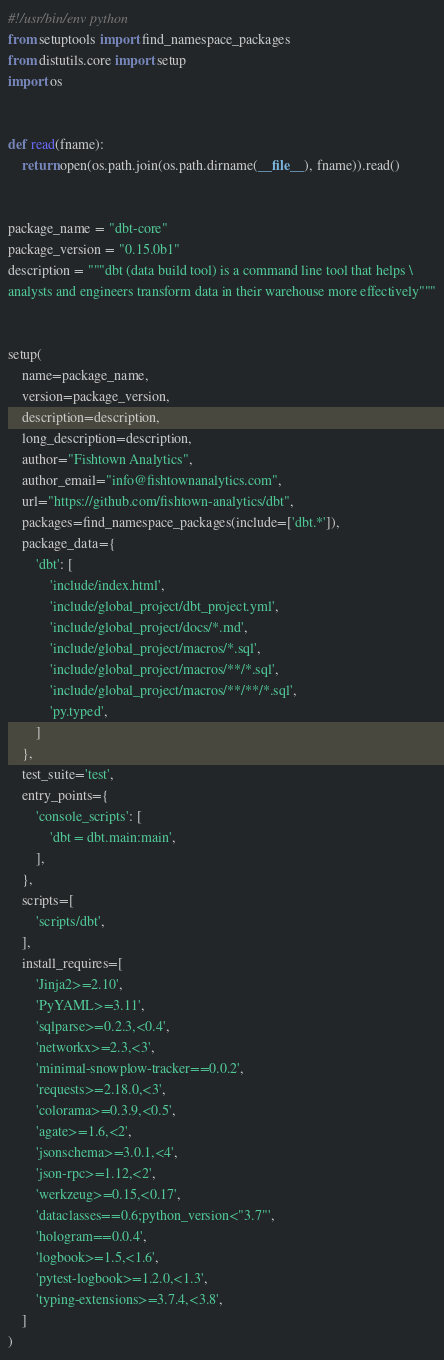Convert code to text. <code><loc_0><loc_0><loc_500><loc_500><_Python_>#!/usr/bin/env python
from setuptools import find_namespace_packages
from distutils.core import setup
import os


def read(fname):
    return open(os.path.join(os.path.dirname(__file__), fname)).read()


package_name = "dbt-core"
package_version = "0.15.0b1"
description = """dbt (data build tool) is a command line tool that helps \
analysts and engineers transform data in their warehouse more effectively"""


setup(
    name=package_name,
    version=package_version,
    description=description,
    long_description=description,
    author="Fishtown Analytics",
    author_email="info@fishtownanalytics.com",
    url="https://github.com/fishtown-analytics/dbt",
    packages=find_namespace_packages(include=['dbt.*']),
    package_data={
        'dbt': [
            'include/index.html',
            'include/global_project/dbt_project.yml',
            'include/global_project/docs/*.md',
            'include/global_project/macros/*.sql',
            'include/global_project/macros/**/*.sql',
            'include/global_project/macros/**/**/*.sql',
            'py.typed',
        ]
    },
    test_suite='test',
    entry_points={
        'console_scripts': [
            'dbt = dbt.main:main',
        ],
    },
    scripts=[
        'scripts/dbt',
    ],
    install_requires=[
        'Jinja2>=2.10',
        'PyYAML>=3.11',
        'sqlparse>=0.2.3,<0.4',
        'networkx>=2.3,<3',
        'minimal-snowplow-tracker==0.0.2',
        'requests>=2.18.0,<3',
        'colorama>=0.3.9,<0.5',
        'agate>=1.6,<2',
        'jsonschema>=3.0.1,<4',
        'json-rpc>=1.12,<2',
        'werkzeug>=0.15,<0.17',
        'dataclasses==0.6;python_version<"3.7"',
        'hologram==0.0.4',
        'logbook>=1.5,<1.6',
        'pytest-logbook>=1.2.0,<1.3',
        'typing-extensions>=3.7.4,<3.8',
    ]
)
</code> 